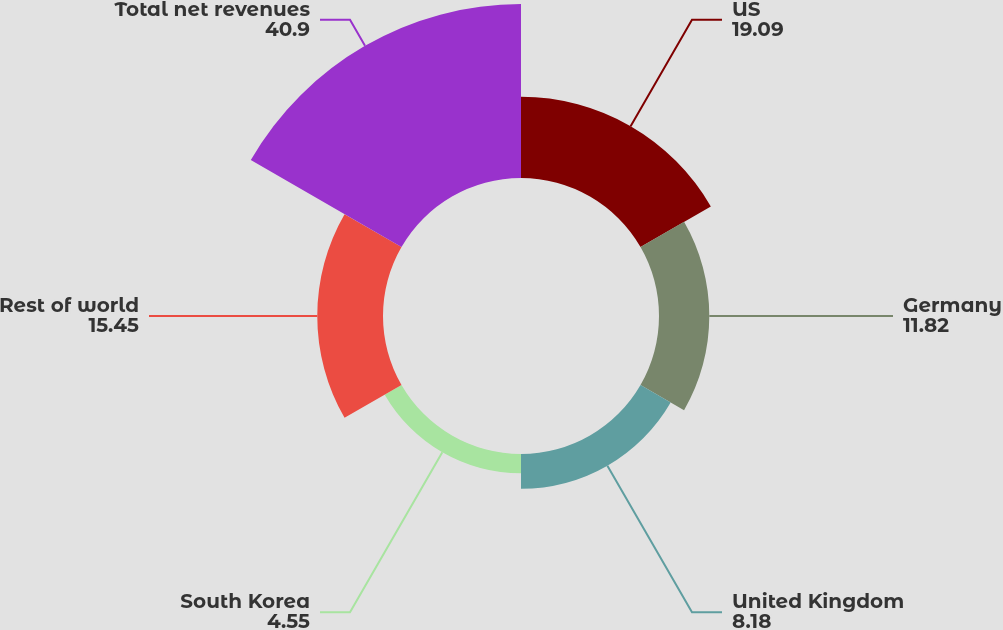Convert chart to OTSL. <chart><loc_0><loc_0><loc_500><loc_500><pie_chart><fcel>US<fcel>Germany<fcel>United Kingdom<fcel>South Korea<fcel>Rest of world<fcel>Total net revenues<nl><fcel>19.09%<fcel>11.82%<fcel>8.18%<fcel>4.55%<fcel>15.45%<fcel>40.9%<nl></chart> 